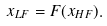Convert formula to latex. <formula><loc_0><loc_0><loc_500><loc_500>x _ { L F } = F ( x _ { H F } ) .</formula> 